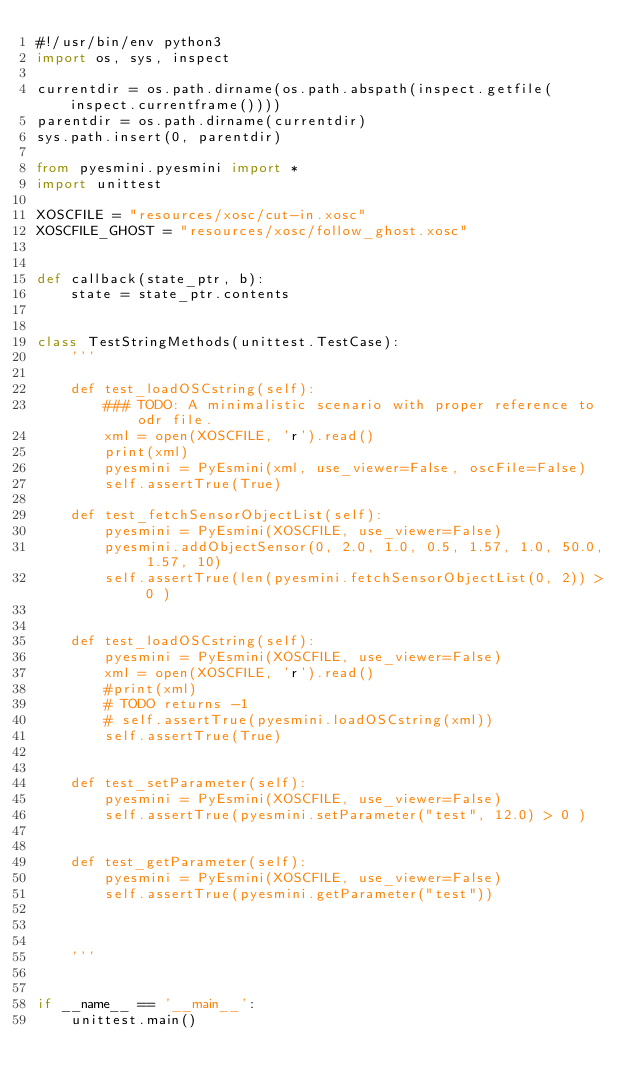Convert code to text. <code><loc_0><loc_0><loc_500><loc_500><_Python_>#!/usr/bin/env python3
import os, sys, inspect

currentdir = os.path.dirname(os.path.abspath(inspect.getfile(inspect.currentframe())))
parentdir = os.path.dirname(currentdir)
sys.path.insert(0, parentdir)

from pyesmini.pyesmini import *
import unittest

XOSCFILE = "resources/xosc/cut-in.xosc"
XOSCFILE_GHOST = "resources/xosc/follow_ghost.xosc"


def callback(state_ptr, b):
    state = state_ptr.contents


class TestStringMethods(unittest.TestCase):
    '''

    def test_loadOSCstring(self):
        ### TODO: A minimalistic scenario with proper reference to odr file.
        xml = open(XOSCFILE, 'r').read()
        print(xml)
        pyesmini = PyEsmini(xml, use_viewer=False, oscFile=False)
        self.assertTrue(True)

    def test_fetchSensorObjectList(self):
        pyesmini = PyEsmini(XOSCFILE, use_viewer=False)
        pyesmini.addObjectSensor(0, 2.0, 1.0, 0.5, 1.57, 1.0, 50.0, 1.57, 10)
        self.assertTrue(len(pyesmini.fetchSensorObjectList(0, 2)) > 0 )


    def test_loadOSCstring(self):
        pyesmini = PyEsmini(XOSCFILE, use_viewer=False)
        xml = open(XOSCFILE, 'r').read()
        #print(xml)
        # TODO returns -1
        # self.assertTrue(pyesmini.loadOSCstring(xml))
        self.assertTrue(True)


    def test_setParameter(self):
        pyesmini = PyEsmini(XOSCFILE, use_viewer=False)
        self.assertTrue(pyesmini.setParameter("test", 12.0) > 0 )


    def test_getParameter(self):
        pyesmini = PyEsmini(XOSCFILE, use_viewer=False)
        self.assertTrue(pyesmini.getParameter("test"))



    '''


if __name__ == '__main__':
    unittest.main()
</code> 